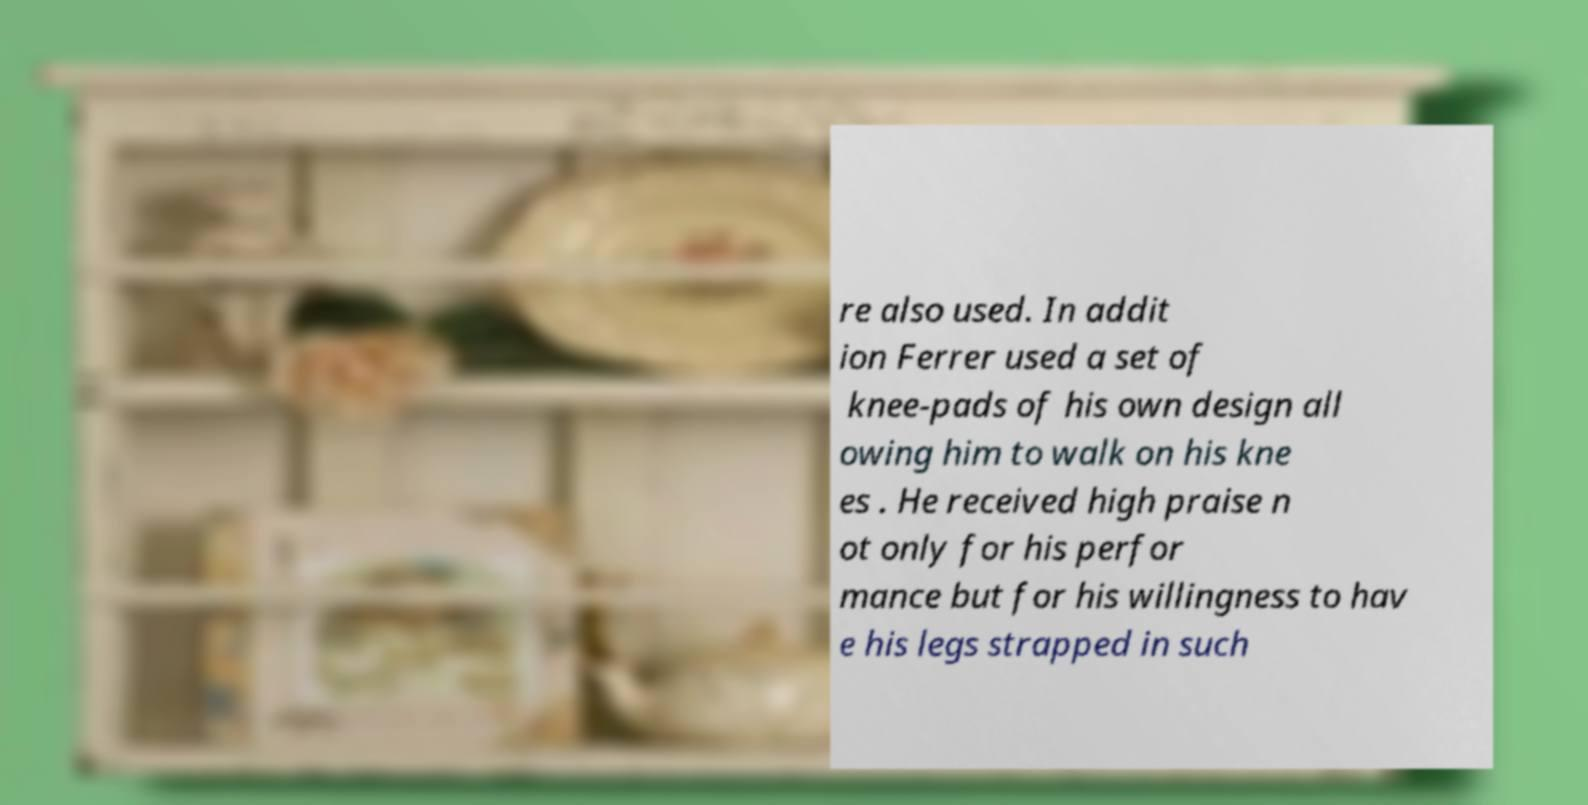What messages or text are displayed in this image? I need them in a readable, typed format. re also used. In addit ion Ferrer used a set of knee-pads of his own design all owing him to walk on his kne es . He received high praise n ot only for his perfor mance but for his willingness to hav e his legs strapped in such 